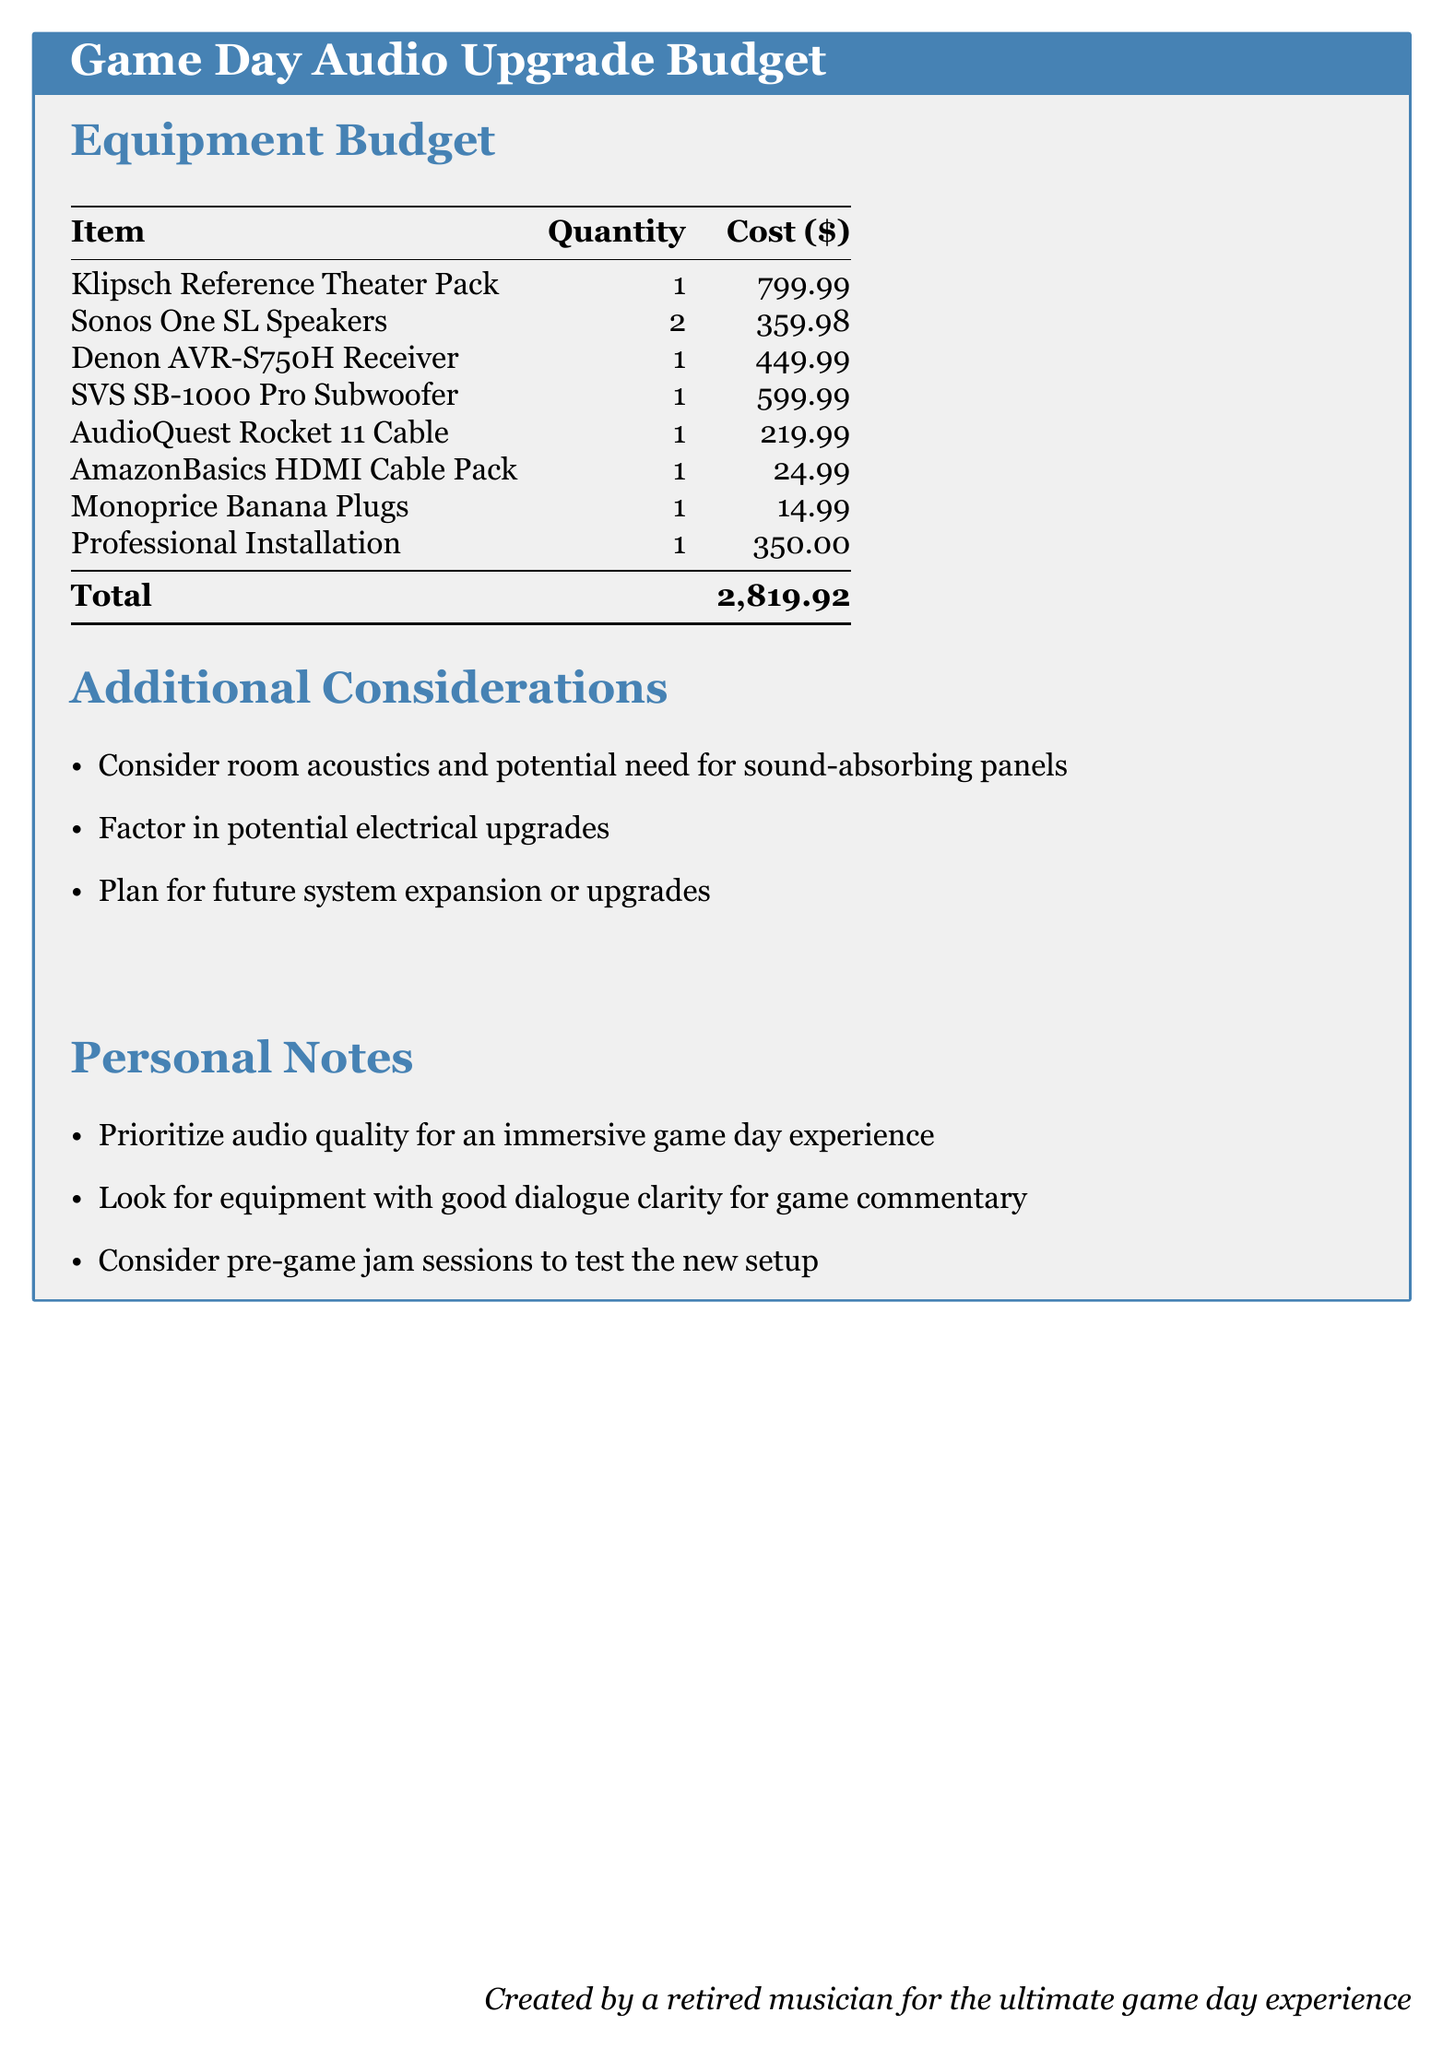What is the total cost of the audio upgrade? The total cost is provided in the budget summary, calculated by adding all item costs.
Answer: 2,819.92 How many Sonos One SL Speakers are included? The quantity of Sonos One SL Speakers is specified in the Equipment Budget table.
Answer: 2 What is the cost of the Denon AVR-S750H Receiver? The cost is listed in the Equipment Budget table for the Denon AVR-S750H Receiver.
Answer: 449.99 What additional consideration involves the physical space? The document mentions considering room acoustics, which affects sound quality.
Answer: Room acoustics What is one personal note related to audio quality? The personal notes section specifies a priority regarding the immersive experience during game day.
Answer: Immersive game day experience What type of installation is mentioned in the budget? The budget includes a line item for Professional Installation, which is necessary for the setup.
Answer: Professional Installation What is the cost for the SVS SB-1000 Pro Subwoofer? The price for the SVS SB-1000 Pro Subwoofer is listed in the Equipment Budget.
Answer: 599.99 What is a suggested consideration for future needs? The document advises planning for future system expansion or upgrades.
Answer: Future system expansion 